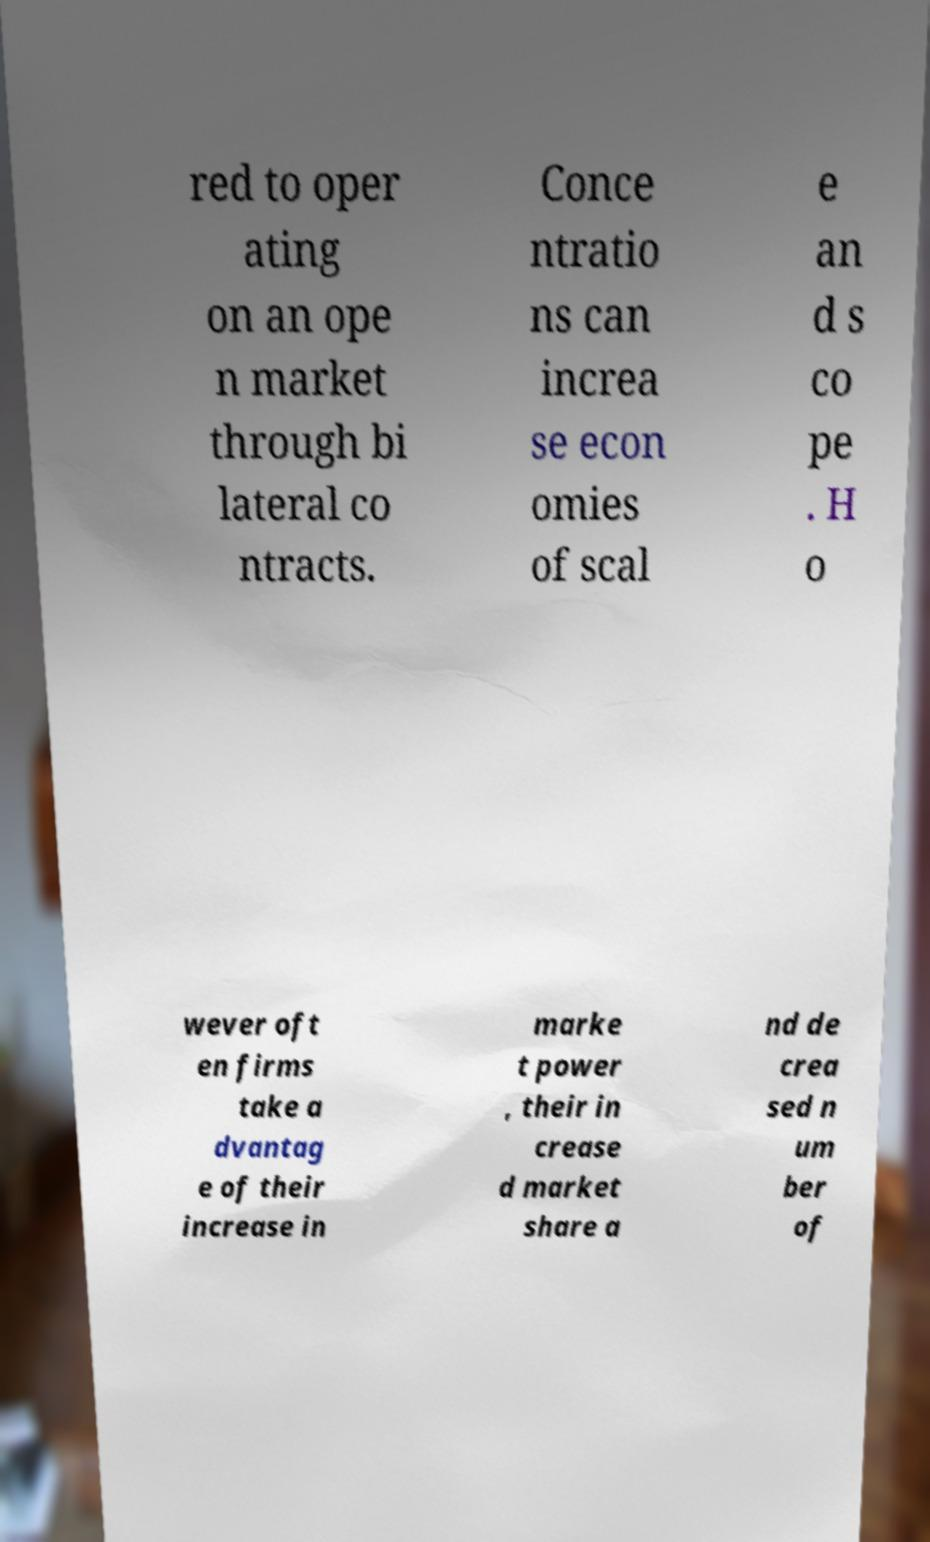Please identify and transcribe the text found in this image. red to oper ating on an ope n market through bi lateral co ntracts. Conce ntratio ns can increa se econ omies of scal e an d s co pe . H o wever oft en firms take a dvantag e of their increase in marke t power , their in crease d market share a nd de crea sed n um ber of 